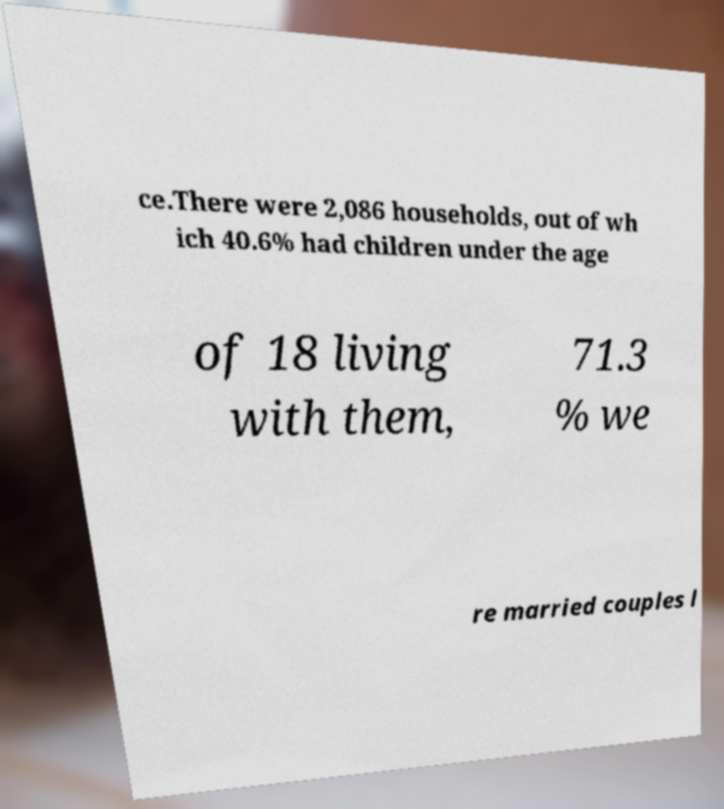There's text embedded in this image that I need extracted. Can you transcribe it verbatim? ce.There were 2,086 households, out of wh ich 40.6% had children under the age of 18 living with them, 71.3 % we re married couples l 